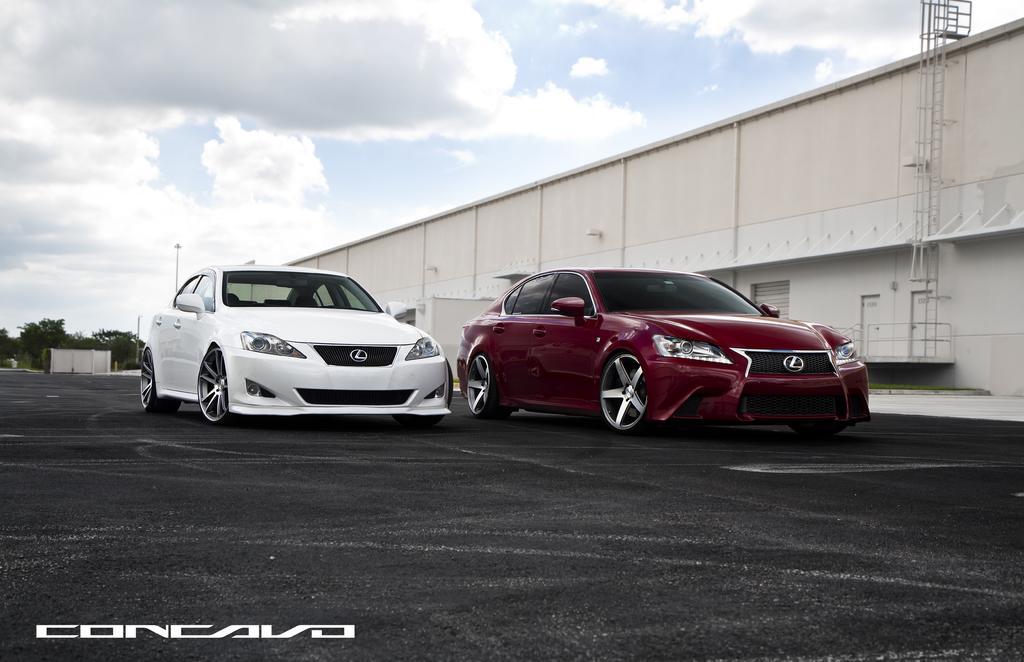In one or two sentences, can you explain what this image depicts? In this image in the center there are cars which are red and white in colour. In the background there are trees and on the right side there is a shed and the sky is cloudy. 